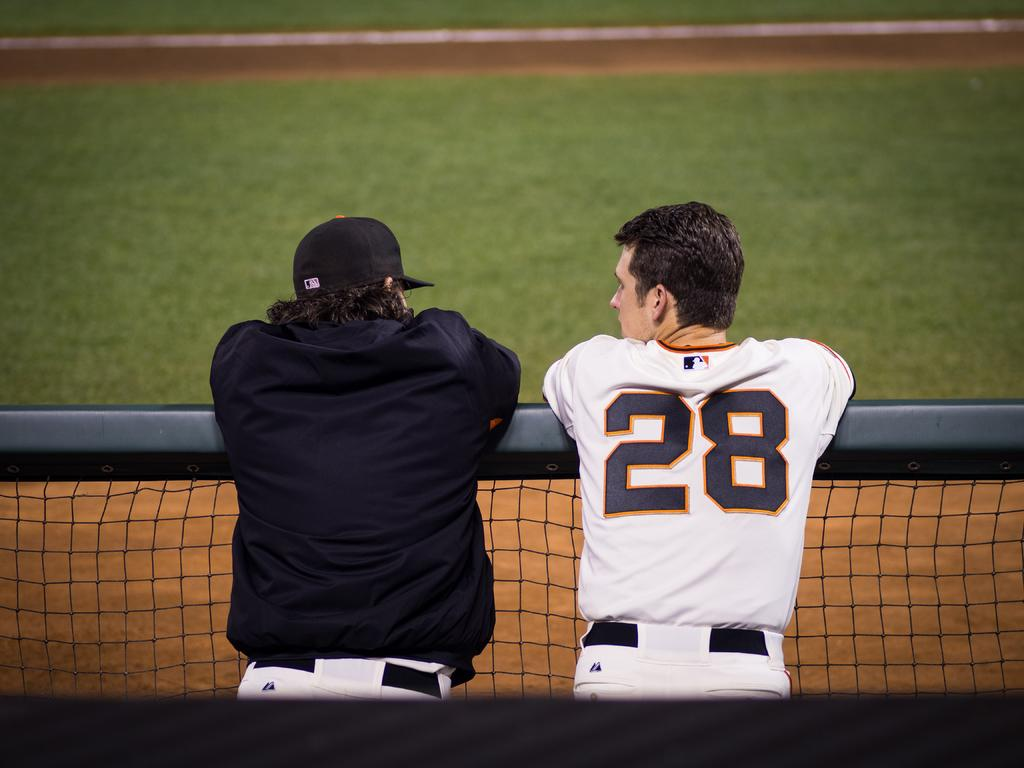<image>
Give a short and clear explanation of the subsequent image. A man wearing number 28 on his jersey talking to another man by a fence. 